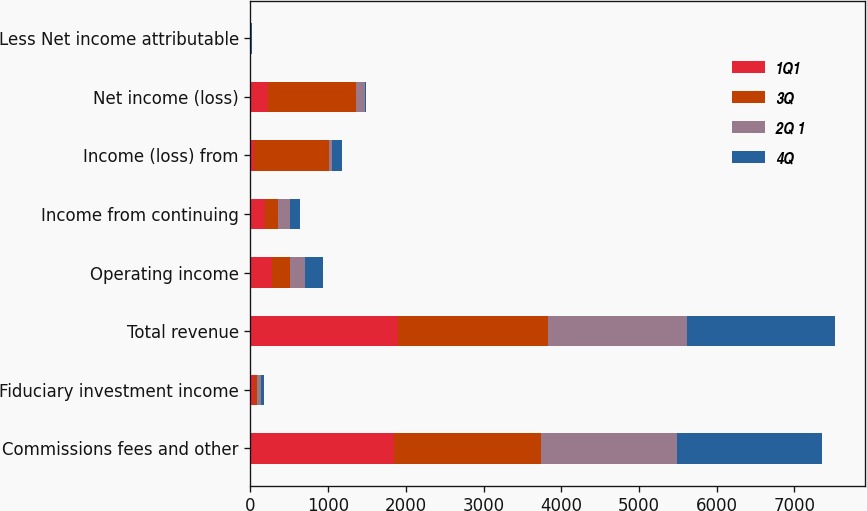Convert chart to OTSL. <chart><loc_0><loc_0><loc_500><loc_500><stacked_bar_chart><ecel><fcel>Commissions fees and other<fcel>Fiduciary investment income<fcel>Total revenue<fcel>Operating income<fcel>Income from continuing<fcel>Income (loss) from<fcel>Net income (loss)<fcel>Less Net income attributable<nl><fcel>1Q1<fcel>1848<fcel>45<fcel>1893<fcel>275<fcel>182<fcel>41<fcel>223<fcel>5<nl><fcel>3Q<fcel>1887<fcel>44<fcel>1931<fcel>230<fcel>169<fcel>967<fcel>1136<fcel>3<nl><fcel>2Q 1<fcel>1754<fcel>44<fcel>1798<fcel>199<fcel>159<fcel>38<fcel>121<fcel>4<nl><fcel>4Q<fcel>1868<fcel>38<fcel>1906<fcel>236<fcel>127<fcel>129<fcel>2<fcel>4<nl></chart> 